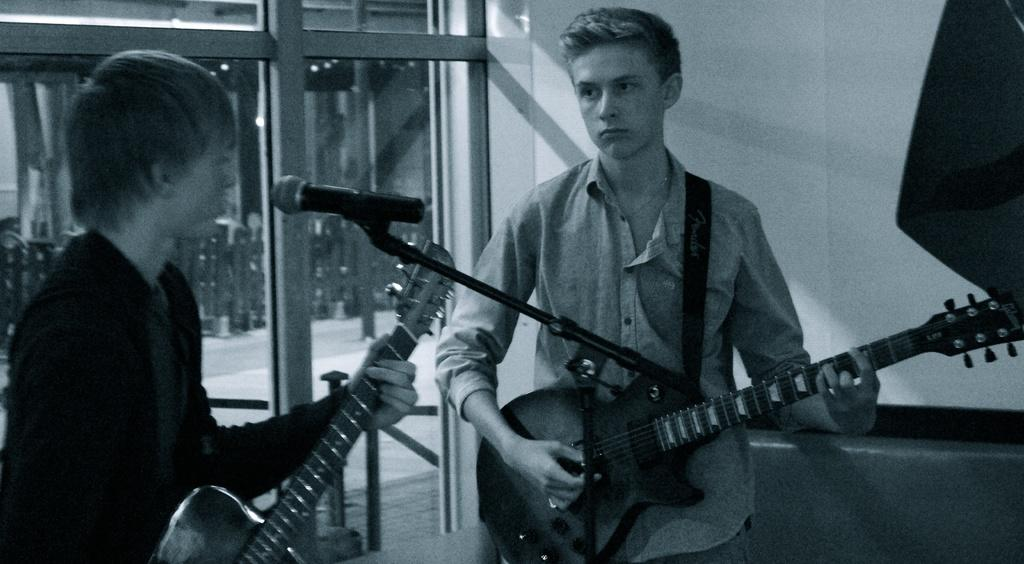How many people are in the image? There are two men in the image. What are the men doing in the image? Both men are standing and holding a guitar. What object is present for amplifying sound? There is a microphone in the image. What is the color scheme of the image? The image is black and white in color. Are there any cats visible in the image? No, there are no cats present in the image. Is the growth of the men in the image affected by quicksand? There is no quicksand present in the image, and therefore it cannot affect the growth of the men. 